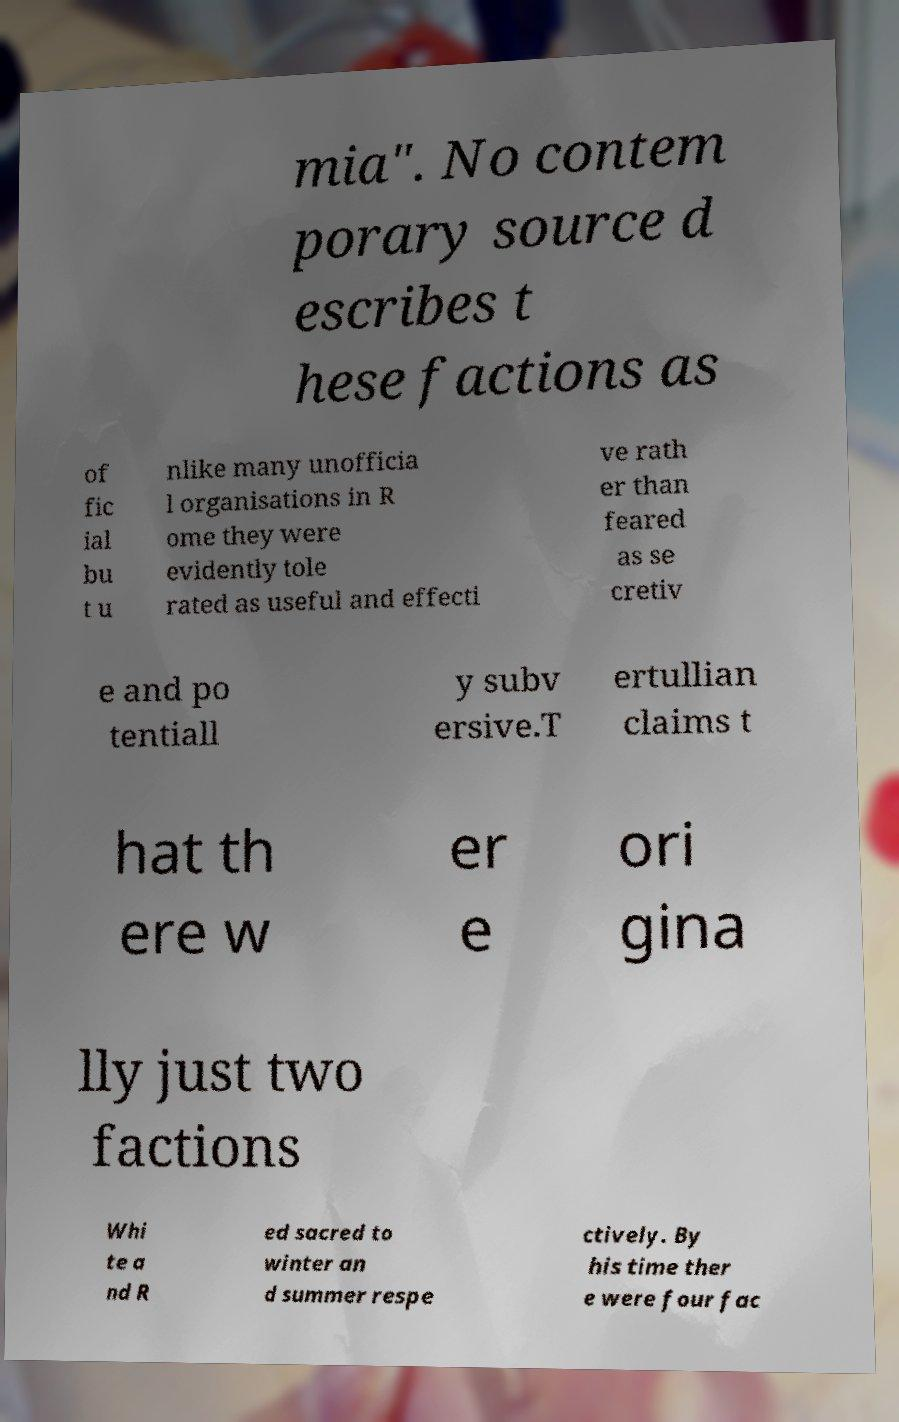Please read and relay the text visible in this image. What does it say? mia". No contem porary source d escribes t hese factions as of fic ial bu t u nlike many unofficia l organisations in R ome they were evidently tole rated as useful and effecti ve rath er than feared as se cretiv e and po tentiall y subv ersive.T ertullian claims t hat th ere w er e ori gina lly just two factions Whi te a nd R ed sacred to winter an d summer respe ctively. By his time ther e were four fac 